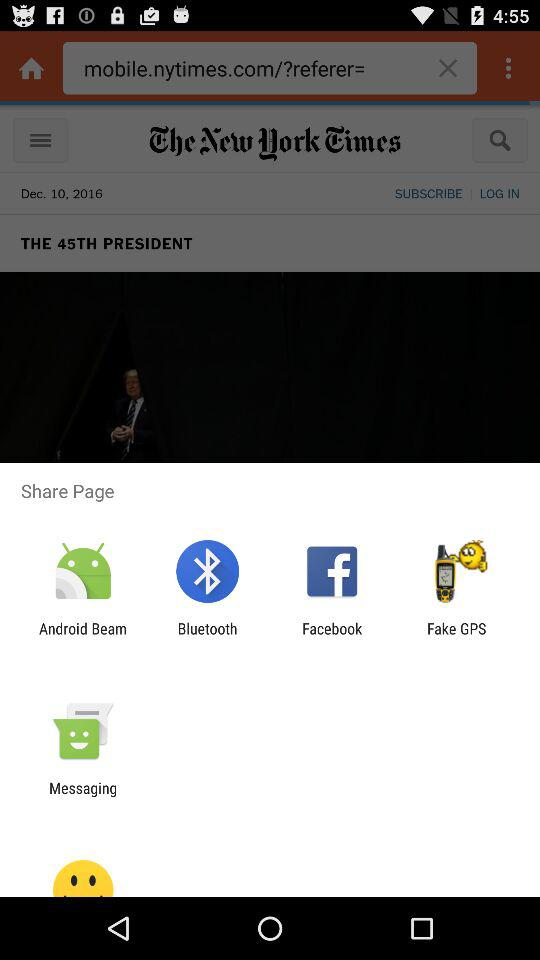Which day of the week is Dec. 10, 2016?
When the provided information is insufficient, respond with <no answer>. <no answer> 